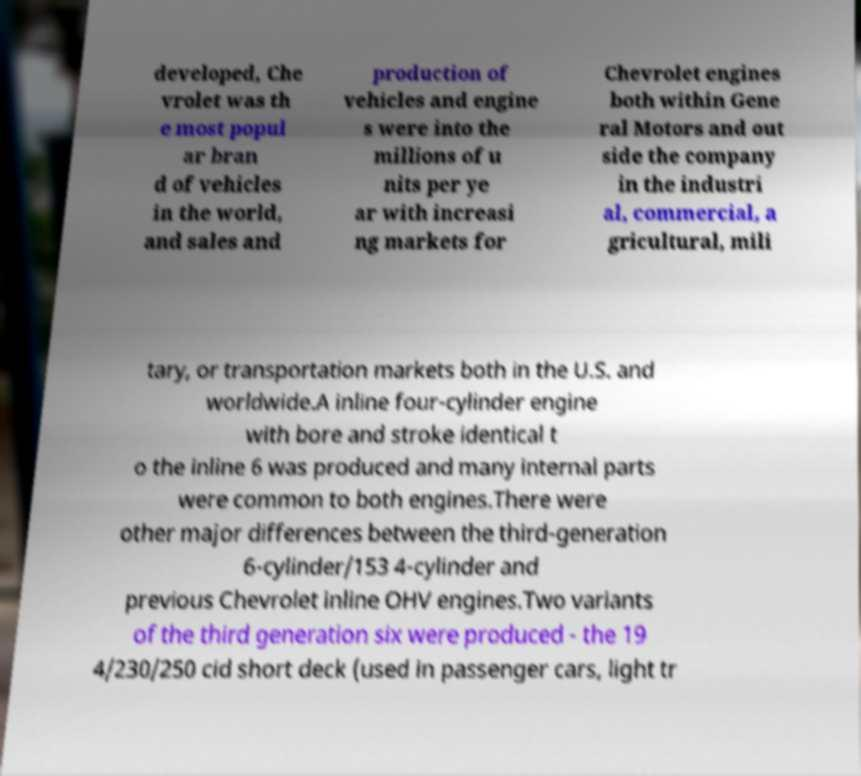Can you accurately transcribe the text from the provided image for me? developed, Che vrolet was th e most popul ar bran d of vehicles in the world, and sales and production of vehicles and engine s were into the millions of u nits per ye ar with increasi ng markets for Chevrolet engines both within Gene ral Motors and out side the company in the industri al, commercial, a gricultural, mili tary, or transportation markets both in the U.S. and worldwide.A inline four-cylinder engine with bore and stroke identical t o the inline 6 was produced and many internal parts were common to both engines.There were other major differences between the third-generation 6-cylinder/153 4-cylinder and previous Chevrolet inline OHV engines.Two variants of the third generation six were produced - the 19 4/230/250 cid short deck (used in passenger cars, light tr 